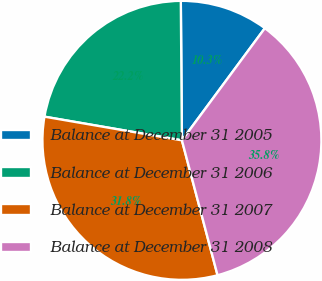<chart> <loc_0><loc_0><loc_500><loc_500><pie_chart><fcel>Balance at December 31 2005<fcel>Balance at December 31 2006<fcel>Balance at December 31 2007<fcel>Balance at December 31 2008<nl><fcel>10.26%<fcel>22.16%<fcel>31.83%<fcel>35.76%<nl></chart> 